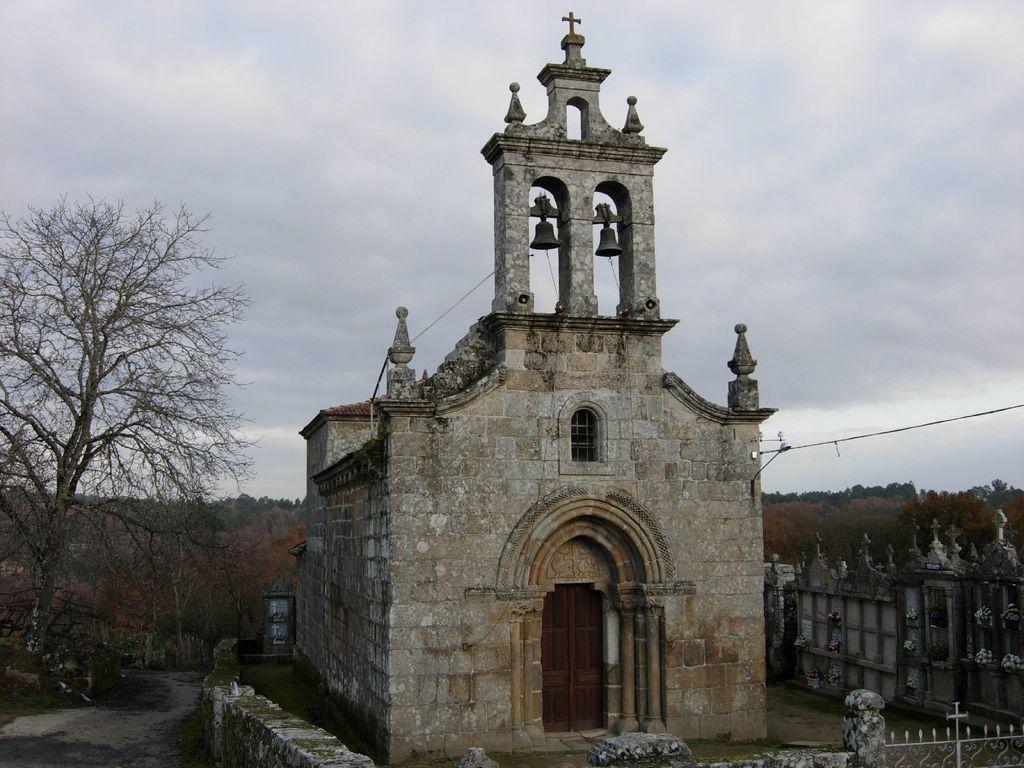Describe this image in one or two sentences. In this picture we can see a building with a window, door, bells, wall, trees, gate and in the background we can see the sky with clouds. 